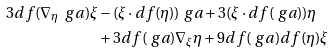<formula> <loc_0><loc_0><loc_500><loc_500>3 d f ( \nabla _ { \eta } \ g a ) \xi & - ( \xi \cdot d f ( \eta ) ) \ g a + 3 ( \xi \cdot d f ( \ g a ) ) \eta \\ & + 3 d f ( \ g a ) \nabla _ { \xi } \eta + 9 d f ( \ g a ) d f ( \eta ) \xi</formula> 